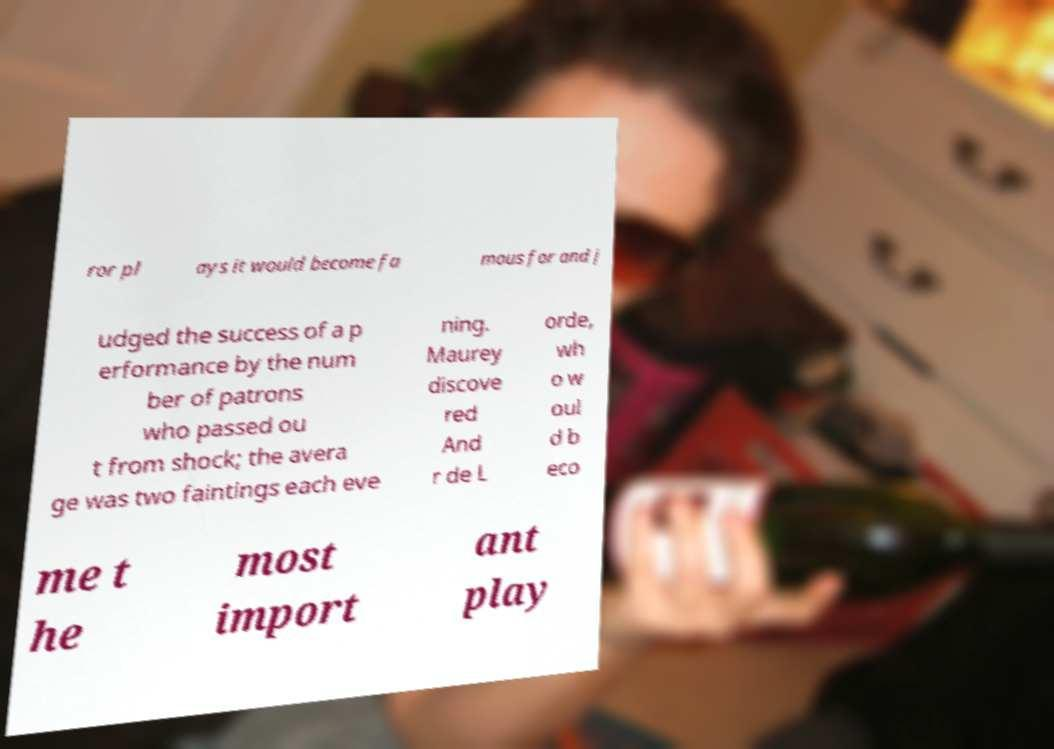Could you assist in decoding the text presented in this image and type it out clearly? ror pl ays it would become fa mous for and j udged the success of a p erformance by the num ber of patrons who passed ou t from shock; the avera ge was two faintings each eve ning. Maurey discove red And r de L orde, wh o w oul d b eco me t he most import ant play 